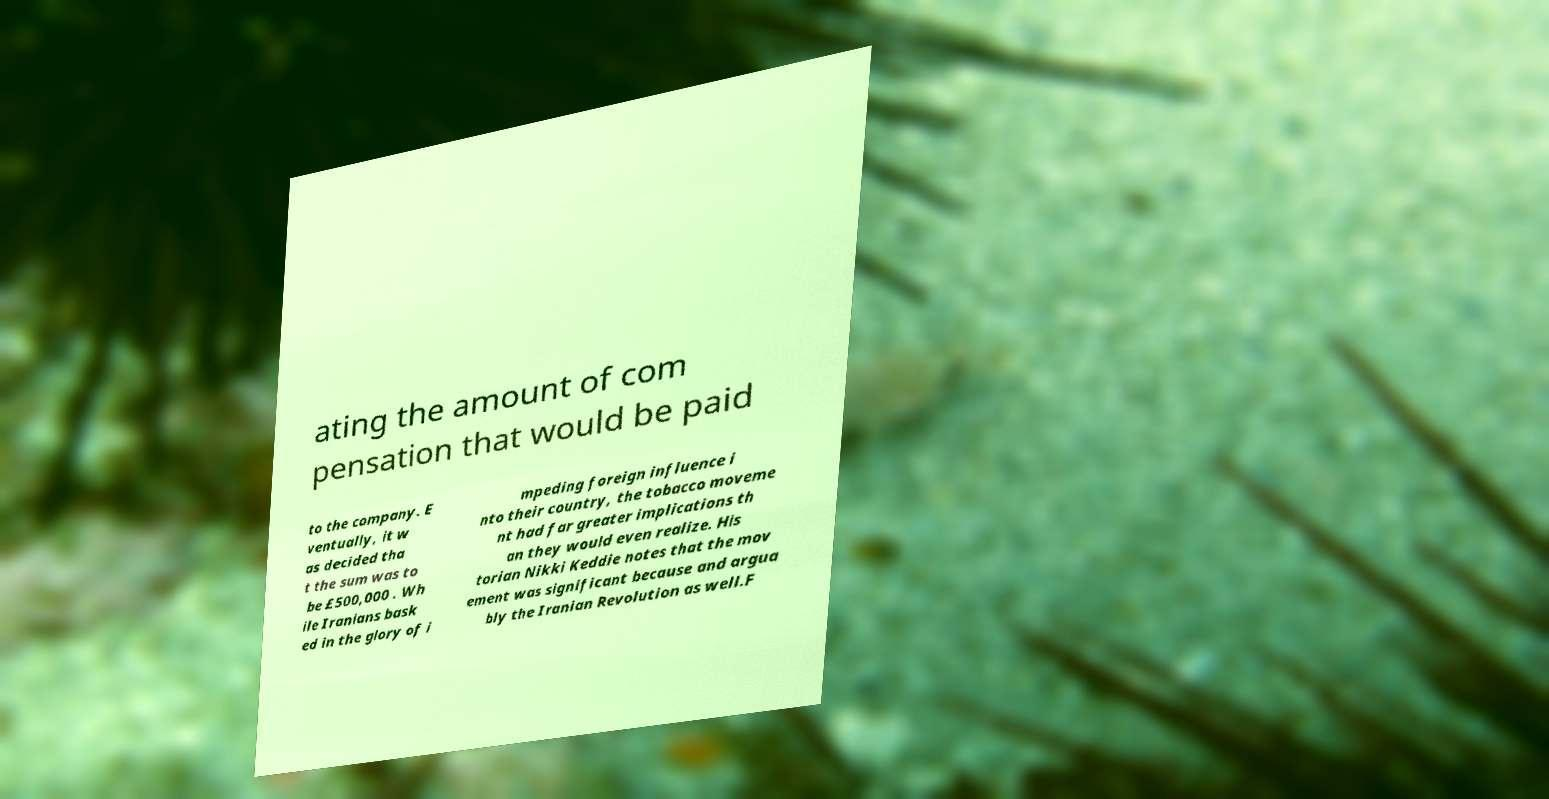Please read and relay the text visible in this image. What does it say? ating the amount of com pensation that would be paid to the company. E ventually, it w as decided tha t the sum was to be £500,000 . Wh ile Iranians bask ed in the glory of i mpeding foreign influence i nto their country, the tobacco moveme nt had far greater implications th an they would even realize. His torian Nikki Keddie notes that the mov ement was significant because and argua bly the Iranian Revolution as well.F 